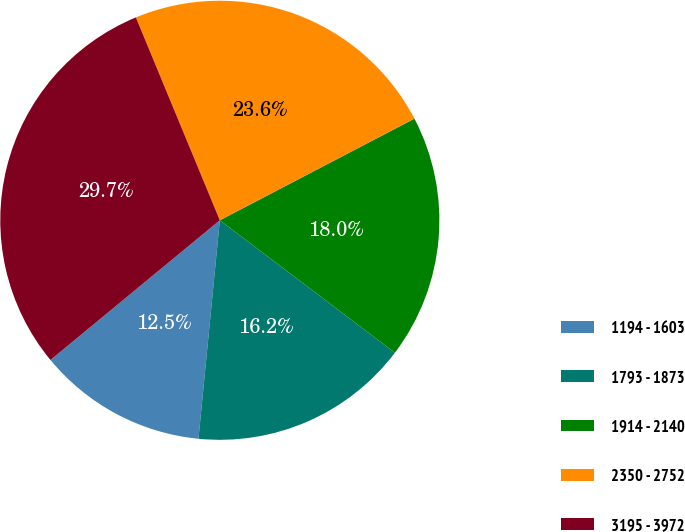Convert chart. <chart><loc_0><loc_0><loc_500><loc_500><pie_chart><fcel>1194 - 1603<fcel>1793 - 1873<fcel>1914 - 2140<fcel>2350 - 2752<fcel>3195 - 3972<nl><fcel>12.47%<fcel>16.24%<fcel>17.97%<fcel>23.58%<fcel>29.73%<nl></chart> 